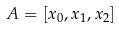<formula> <loc_0><loc_0><loc_500><loc_500>A = [ x _ { 0 } , x _ { 1 } , x _ { 2 } ]</formula> 